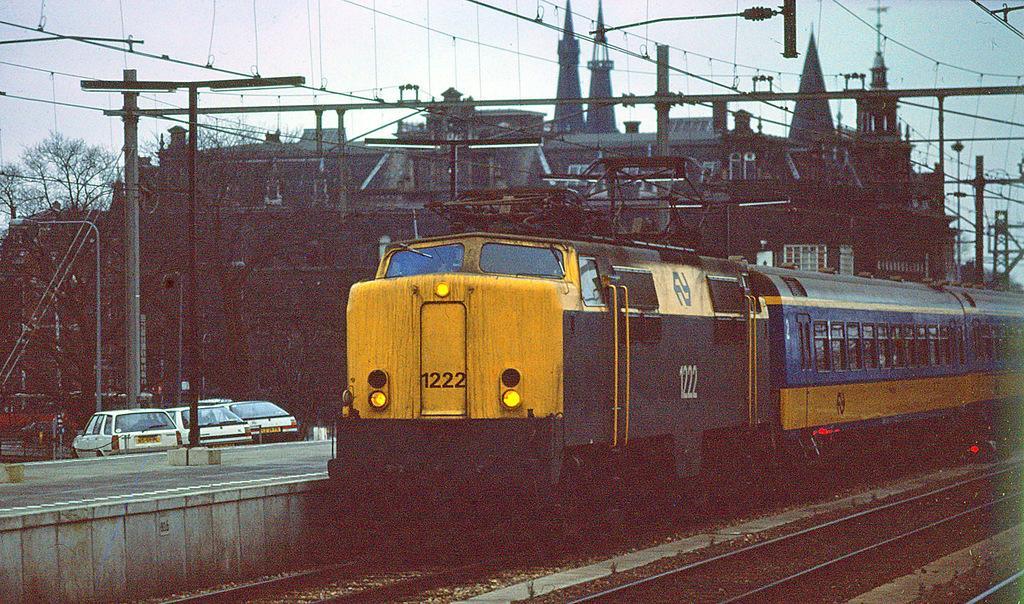Can you describe this image briefly? In the center of the image we can see a train engine with wagons attached to it. On the left side of the image we can see a group of cars parked on the road. In the background, we can see a group of poles, lights, building and the sky. 